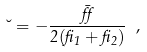Convert formula to latex. <formula><loc_0><loc_0><loc_500><loc_500>\lambda = - \frac { \bar { \alpha } } { 2 ( \beta _ { 1 } + \beta _ { 2 } ) } \ ,</formula> 